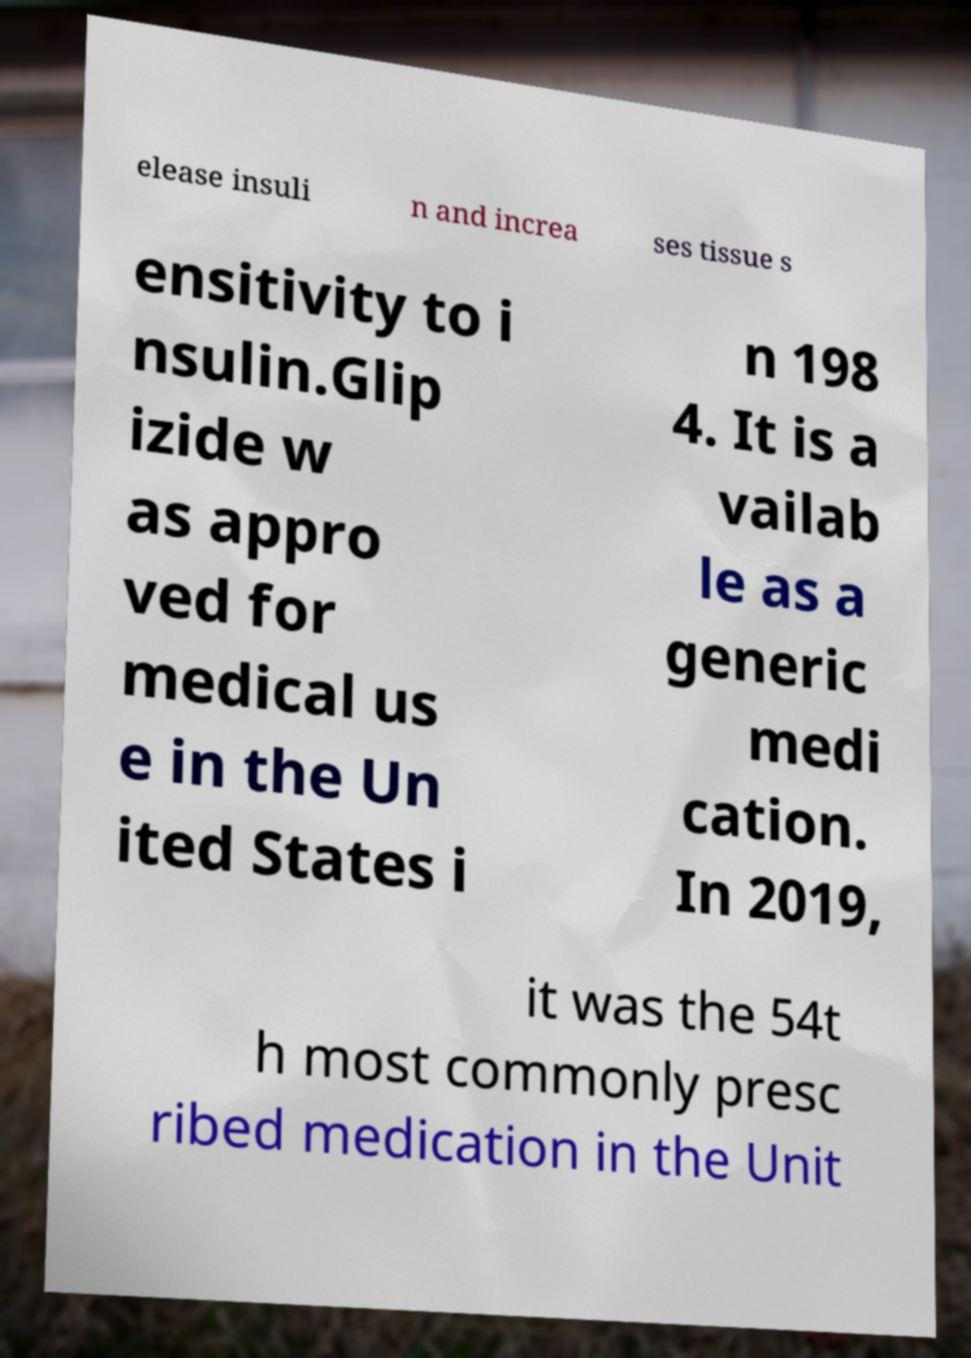There's text embedded in this image that I need extracted. Can you transcribe it verbatim? elease insuli n and increa ses tissue s ensitivity to i nsulin.Glip izide w as appro ved for medical us e in the Un ited States i n 198 4. It is a vailab le as a generic medi cation. In 2019, it was the 54t h most commonly presc ribed medication in the Unit 